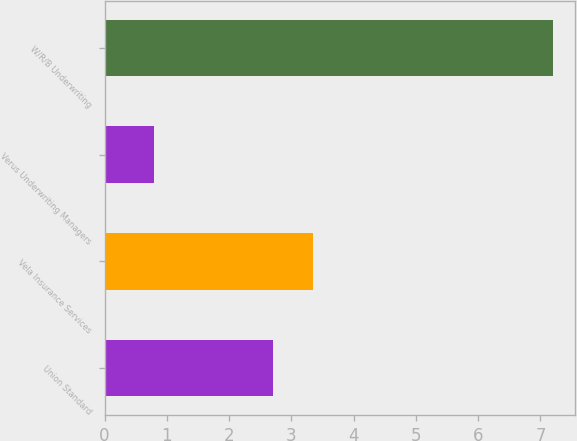Convert chart. <chart><loc_0><loc_0><loc_500><loc_500><bar_chart><fcel>Union Standard<fcel>Vela Insurance Services<fcel>Verus Underwriting Managers<fcel>W/R/B Underwriting<nl><fcel>2.7<fcel>3.34<fcel>0.8<fcel>7.2<nl></chart> 